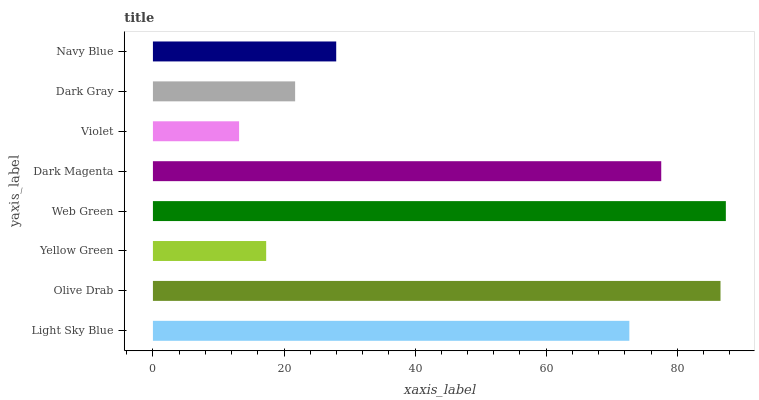Is Violet the minimum?
Answer yes or no. Yes. Is Web Green the maximum?
Answer yes or no. Yes. Is Olive Drab the minimum?
Answer yes or no. No. Is Olive Drab the maximum?
Answer yes or no. No. Is Olive Drab greater than Light Sky Blue?
Answer yes or no. Yes. Is Light Sky Blue less than Olive Drab?
Answer yes or no. Yes. Is Light Sky Blue greater than Olive Drab?
Answer yes or no. No. Is Olive Drab less than Light Sky Blue?
Answer yes or no. No. Is Light Sky Blue the high median?
Answer yes or no. Yes. Is Navy Blue the low median?
Answer yes or no. Yes. Is Yellow Green the high median?
Answer yes or no. No. Is Light Sky Blue the low median?
Answer yes or no. No. 